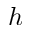<formula> <loc_0><loc_0><loc_500><loc_500>h</formula> 